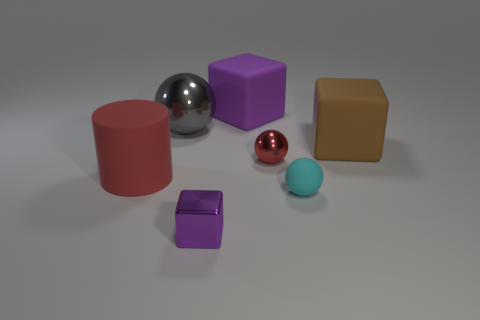What materials do the objects in the image appear to be made of? The objects in the image appear to be made of various materials. The shiny sphere and the smaller ball both look metallic, while the cubes and the cylinder seem to be made of a matte substance, perhaps plastic or painted wood. 